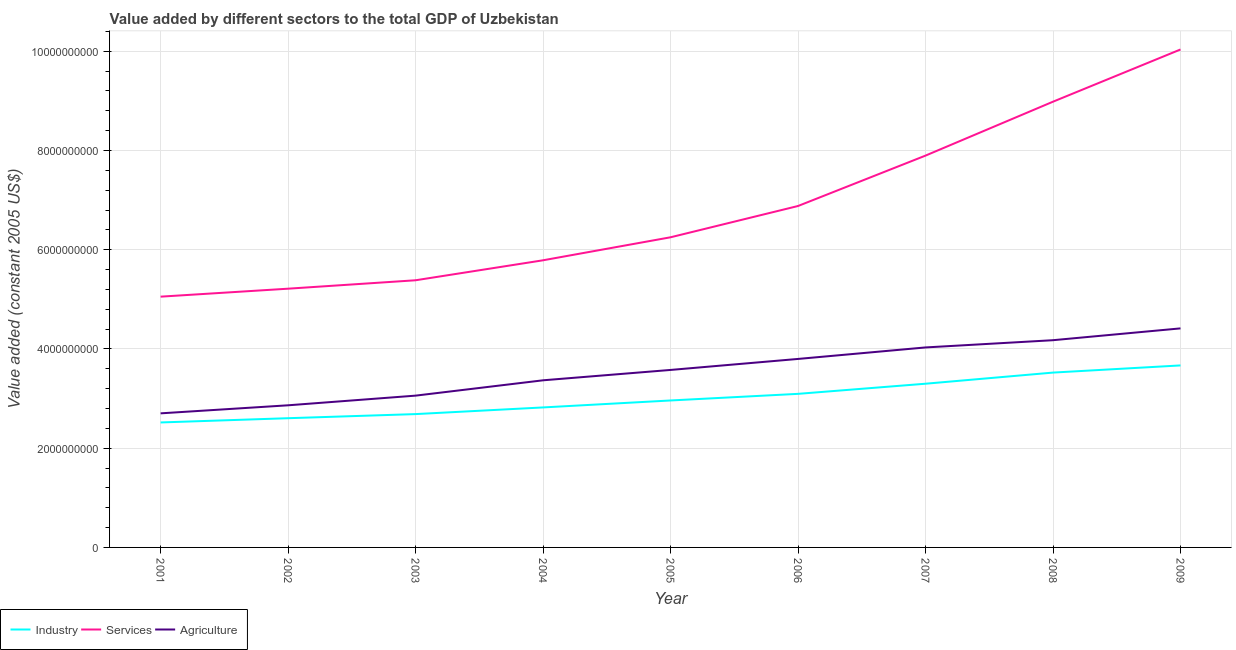How many different coloured lines are there?
Provide a succinct answer. 3. Does the line corresponding to value added by industrial sector intersect with the line corresponding to value added by agricultural sector?
Offer a very short reply. No. What is the value added by agricultural sector in 2001?
Give a very brief answer. 2.70e+09. Across all years, what is the maximum value added by agricultural sector?
Offer a very short reply. 4.41e+09. Across all years, what is the minimum value added by agricultural sector?
Provide a succinct answer. 2.70e+09. In which year was the value added by agricultural sector minimum?
Ensure brevity in your answer.  2001. What is the total value added by industrial sector in the graph?
Give a very brief answer. 2.72e+1. What is the difference between the value added by agricultural sector in 2002 and that in 2009?
Ensure brevity in your answer.  -1.55e+09. What is the difference between the value added by industrial sector in 2008 and the value added by agricultural sector in 2004?
Ensure brevity in your answer.  1.55e+08. What is the average value added by agricultural sector per year?
Your response must be concise. 3.55e+09. In the year 2004, what is the difference between the value added by industrial sector and value added by services?
Provide a succinct answer. -2.97e+09. What is the ratio of the value added by services in 2002 to that in 2009?
Your answer should be compact. 0.52. What is the difference between the highest and the second highest value added by industrial sector?
Your answer should be compact. 1.44e+08. What is the difference between the highest and the lowest value added by services?
Offer a very short reply. 4.98e+09. In how many years, is the value added by industrial sector greater than the average value added by industrial sector taken over all years?
Give a very brief answer. 4. Is the sum of the value added by services in 2002 and 2009 greater than the maximum value added by agricultural sector across all years?
Ensure brevity in your answer.  Yes. Is it the case that in every year, the sum of the value added by industrial sector and value added by services is greater than the value added by agricultural sector?
Offer a terse response. Yes. Is the value added by agricultural sector strictly less than the value added by services over the years?
Your answer should be compact. Yes. How many lines are there?
Provide a short and direct response. 3. What is the difference between two consecutive major ticks on the Y-axis?
Keep it short and to the point. 2.00e+09. Where does the legend appear in the graph?
Your answer should be compact. Bottom left. How many legend labels are there?
Your answer should be very brief. 3. What is the title of the graph?
Provide a succinct answer. Value added by different sectors to the total GDP of Uzbekistan. Does "Oil" appear as one of the legend labels in the graph?
Your answer should be compact. No. What is the label or title of the X-axis?
Give a very brief answer. Year. What is the label or title of the Y-axis?
Your answer should be compact. Value added (constant 2005 US$). What is the Value added (constant 2005 US$) of Industry in 2001?
Provide a succinct answer. 2.52e+09. What is the Value added (constant 2005 US$) in Services in 2001?
Provide a short and direct response. 5.05e+09. What is the Value added (constant 2005 US$) of Agriculture in 2001?
Provide a short and direct response. 2.70e+09. What is the Value added (constant 2005 US$) in Industry in 2002?
Your answer should be very brief. 2.60e+09. What is the Value added (constant 2005 US$) in Services in 2002?
Your answer should be very brief. 5.21e+09. What is the Value added (constant 2005 US$) of Agriculture in 2002?
Your answer should be compact. 2.86e+09. What is the Value added (constant 2005 US$) in Industry in 2003?
Give a very brief answer. 2.69e+09. What is the Value added (constant 2005 US$) of Services in 2003?
Provide a succinct answer. 5.38e+09. What is the Value added (constant 2005 US$) of Agriculture in 2003?
Provide a short and direct response. 3.06e+09. What is the Value added (constant 2005 US$) in Industry in 2004?
Offer a very short reply. 2.82e+09. What is the Value added (constant 2005 US$) of Services in 2004?
Offer a terse response. 5.79e+09. What is the Value added (constant 2005 US$) in Agriculture in 2004?
Keep it short and to the point. 3.37e+09. What is the Value added (constant 2005 US$) of Industry in 2005?
Keep it short and to the point. 2.96e+09. What is the Value added (constant 2005 US$) of Services in 2005?
Your answer should be compact. 6.25e+09. What is the Value added (constant 2005 US$) in Agriculture in 2005?
Offer a terse response. 3.58e+09. What is the Value added (constant 2005 US$) of Industry in 2006?
Your response must be concise. 3.09e+09. What is the Value added (constant 2005 US$) of Services in 2006?
Provide a short and direct response. 6.88e+09. What is the Value added (constant 2005 US$) of Agriculture in 2006?
Provide a succinct answer. 3.80e+09. What is the Value added (constant 2005 US$) in Industry in 2007?
Provide a succinct answer. 3.30e+09. What is the Value added (constant 2005 US$) in Services in 2007?
Give a very brief answer. 7.90e+09. What is the Value added (constant 2005 US$) in Agriculture in 2007?
Your response must be concise. 4.03e+09. What is the Value added (constant 2005 US$) in Industry in 2008?
Offer a terse response. 3.52e+09. What is the Value added (constant 2005 US$) in Services in 2008?
Offer a very short reply. 8.98e+09. What is the Value added (constant 2005 US$) of Agriculture in 2008?
Offer a terse response. 4.18e+09. What is the Value added (constant 2005 US$) in Industry in 2009?
Your answer should be compact. 3.67e+09. What is the Value added (constant 2005 US$) in Services in 2009?
Give a very brief answer. 1.00e+1. What is the Value added (constant 2005 US$) of Agriculture in 2009?
Your response must be concise. 4.41e+09. Across all years, what is the maximum Value added (constant 2005 US$) of Industry?
Offer a terse response. 3.67e+09. Across all years, what is the maximum Value added (constant 2005 US$) of Services?
Your answer should be compact. 1.00e+1. Across all years, what is the maximum Value added (constant 2005 US$) of Agriculture?
Give a very brief answer. 4.41e+09. Across all years, what is the minimum Value added (constant 2005 US$) of Industry?
Provide a succinct answer. 2.52e+09. Across all years, what is the minimum Value added (constant 2005 US$) in Services?
Give a very brief answer. 5.05e+09. Across all years, what is the minimum Value added (constant 2005 US$) of Agriculture?
Make the answer very short. 2.70e+09. What is the total Value added (constant 2005 US$) in Industry in the graph?
Offer a very short reply. 2.72e+1. What is the total Value added (constant 2005 US$) in Services in the graph?
Your answer should be compact. 6.15e+1. What is the total Value added (constant 2005 US$) of Agriculture in the graph?
Offer a terse response. 3.20e+1. What is the difference between the Value added (constant 2005 US$) in Industry in 2001 and that in 2002?
Your answer should be compact. -8.56e+07. What is the difference between the Value added (constant 2005 US$) in Services in 2001 and that in 2002?
Your response must be concise. -1.60e+08. What is the difference between the Value added (constant 2005 US$) of Agriculture in 2001 and that in 2002?
Your answer should be compact. -1.62e+08. What is the difference between the Value added (constant 2005 US$) in Industry in 2001 and that in 2003?
Provide a succinct answer. -1.68e+08. What is the difference between the Value added (constant 2005 US$) of Services in 2001 and that in 2003?
Offer a terse response. -3.30e+08. What is the difference between the Value added (constant 2005 US$) of Agriculture in 2001 and that in 2003?
Offer a very short reply. -3.57e+08. What is the difference between the Value added (constant 2005 US$) of Industry in 2001 and that in 2004?
Your answer should be compact. -3.03e+08. What is the difference between the Value added (constant 2005 US$) of Services in 2001 and that in 2004?
Give a very brief answer. -7.33e+08. What is the difference between the Value added (constant 2005 US$) of Agriculture in 2001 and that in 2004?
Ensure brevity in your answer.  -6.66e+08. What is the difference between the Value added (constant 2005 US$) of Industry in 2001 and that in 2005?
Make the answer very short. -4.43e+08. What is the difference between the Value added (constant 2005 US$) of Services in 2001 and that in 2005?
Offer a very short reply. -1.20e+09. What is the difference between the Value added (constant 2005 US$) in Agriculture in 2001 and that in 2005?
Your answer should be compact. -8.75e+08. What is the difference between the Value added (constant 2005 US$) in Industry in 2001 and that in 2006?
Offer a very short reply. -5.76e+08. What is the difference between the Value added (constant 2005 US$) in Services in 2001 and that in 2006?
Ensure brevity in your answer.  -1.83e+09. What is the difference between the Value added (constant 2005 US$) of Agriculture in 2001 and that in 2006?
Give a very brief answer. -1.10e+09. What is the difference between the Value added (constant 2005 US$) in Industry in 2001 and that in 2007?
Provide a succinct answer. -7.81e+08. What is the difference between the Value added (constant 2005 US$) of Services in 2001 and that in 2007?
Give a very brief answer. -2.84e+09. What is the difference between the Value added (constant 2005 US$) of Agriculture in 2001 and that in 2007?
Keep it short and to the point. -1.33e+09. What is the difference between the Value added (constant 2005 US$) in Industry in 2001 and that in 2008?
Keep it short and to the point. -1.00e+09. What is the difference between the Value added (constant 2005 US$) in Services in 2001 and that in 2008?
Your answer should be very brief. -3.93e+09. What is the difference between the Value added (constant 2005 US$) in Agriculture in 2001 and that in 2008?
Your response must be concise. -1.47e+09. What is the difference between the Value added (constant 2005 US$) in Industry in 2001 and that in 2009?
Your answer should be very brief. -1.15e+09. What is the difference between the Value added (constant 2005 US$) of Services in 2001 and that in 2009?
Offer a very short reply. -4.98e+09. What is the difference between the Value added (constant 2005 US$) in Agriculture in 2001 and that in 2009?
Provide a succinct answer. -1.71e+09. What is the difference between the Value added (constant 2005 US$) in Industry in 2002 and that in 2003?
Your answer should be compact. -8.27e+07. What is the difference between the Value added (constant 2005 US$) of Services in 2002 and that in 2003?
Provide a short and direct response. -1.70e+08. What is the difference between the Value added (constant 2005 US$) in Agriculture in 2002 and that in 2003?
Offer a very short reply. -1.95e+08. What is the difference between the Value added (constant 2005 US$) in Industry in 2002 and that in 2004?
Offer a terse response. -2.17e+08. What is the difference between the Value added (constant 2005 US$) of Services in 2002 and that in 2004?
Ensure brevity in your answer.  -5.72e+08. What is the difference between the Value added (constant 2005 US$) in Agriculture in 2002 and that in 2004?
Your answer should be compact. -5.04e+08. What is the difference between the Value added (constant 2005 US$) in Industry in 2002 and that in 2005?
Provide a short and direct response. -3.57e+08. What is the difference between the Value added (constant 2005 US$) of Services in 2002 and that in 2005?
Provide a short and direct response. -1.04e+09. What is the difference between the Value added (constant 2005 US$) in Agriculture in 2002 and that in 2005?
Offer a terse response. -7.13e+08. What is the difference between the Value added (constant 2005 US$) in Industry in 2002 and that in 2006?
Ensure brevity in your answer.  -4.91e+08. What is the difference between the Value added (constant 2005 US$) of Services in 2002 and that in 2006?
Offer a very short reply. -1.67e+09. What is the difference between the Value added (constant 2005 US$) of Agriculture in 2002 and that in 2006?
Provide a succinct answer. -9.34e+08. What is the difference between the Value added (constant 2005 US$) in Industry in 2002 and that in 2007?
Provide a succinct answer. -6.95e+08. What is the difference between the Value added (constant 2005 US$) of Services in 2002 and that in 2007?
Your answer should be very brief. -2.68e+09. What is the difference between the Value added (constant 2005 US$) in Agriculture in 2002 and that in 2007?
Your response must be concise. -1.17e+09. What is the difference between the Value added (constant 2005 US$) in Industry in 2002 and that in 2008?
Your response must be concise. -9.19e+08. What is the difference between the Value added (constant 2005 US$) of Services in 2002 and that in 2008?
Provide a short and direct response. -3.77e+09. What is the difference between the Value added (constant 2005 US$) in Agriculture in 2002 and that in 2008?
Offer a very short reply. -1.31e+09. What is the difference between the Value added (constant 2005 US$) in Industry in 2002 and that in 2009?
Make the answer very short. -1.06e+09. What is the difference between the Value added (constant 2005 US$) in Services in 2002 and that in 2009?
Ensure brevity in your answer.  -4.82e+09. What is the difference between the Value added (constant 2005 US$) in Agriculture in 2002 and that in 2009?
Keep it short and to the point. -1.55e+09. What is the difference between the Value added (constant 2005 US$) in Industry in 2003 and that in 2004?
Ensure brevity in your answer.  -1.34e+08. What is the difference between the Value added (constant 2005 US$) in Services in 2003 and that in 2004?
Provide a succinct answer. -4.03e+08. What is the difference between the Value added (constant 2005 US$) in Agriculture in 2003 and that in 2004?
Offer a terse response. -3.09e+08. What is the difference between the Value added (constant 2005 US$) in Industry in 2003 and that in 2005?
Ensure brevity in your answer.  -2.75e+08. What is the difference between the Value added (constant 2005 US$) in Services in 2003 and that in 2005?
Make the answer very short. -8.66e+08. What is the difference between the Value added (constant 2005 US$) in Agriculture in 2003 and that in 2005?
Provide a short and direct response. -5.18e+08. What is the difference between the Value added (constant 2005 US$) in Industry in 2003 and that in 2006?
Offer a very short reply. -4.08e+08. What is the difference between the Value added (constant 2005 US$) in Services in 2003 and that in 2006?
Your response must be concise. -1.50e+09. What is the difference between the Value added (constant 2005 US$) of Agriculture in 2003 and that in 2006?
Your response must be concise. -7.40e+08. What is the difference between the Value added (constant 2005 US$) in Industry in 2003 and that in 2007?
Provide a succinct answer. -6.12e+08. What is the difference between the Value added (constant 2005 US$) in Services in 2003 and that in 2007?
Offer a terse response. -2.51e+09. What is the difference between the Value added (constant 2005 US$) in Agriculture in 2003 and that in 2007?
Your answer should be very brief. -9.71e+08. What is the difference between the Value added (constant 2005 US$) of Industry in 2003 and that in 2008?
Offer a terse response. -8.37e+08. What is the difference between the Value added (constant 2005 US$) of Services in 2003 and that in 2008?
Make the answer very short. -3.60e+09. What is the difference between the Value added (constant 2005 US$) in Agriculture in 2003 and that in 2008?
Provide a succinct answer. -1.12e+09. What is the difference between the Value added (constant 2005 US$) of Industry in 2003 and that in 2009?
Give a very brief answer. -9.81e+08. What is the difference between the Value added (constant 2005 US$) in Services in 2003 and that in 2009?
Give a very brief answer. -4.65e+09. What is the difference between the Value added (constant 2005 US$) in Agriculture in 2003 and that in 2009?
Keep it short and to the point. -1.36e+09. What is the difference between the Value added (constant 2005 US$) of Industry in 2004 and that in 2005?
Your answer should be compact. -1.40e+08. What is the difference between the Value added (constant 2005 US$) of Services in 2004 and that in 2005?
Offer a terse response. -4.64e+08. What is the difference between the Value added (constant 2005 US$) in Agriculture in 2004 and that in 2005?
Provide a succinct answer. -2.09e+08. What is the difference between the Value added (constant 2005 US$) in Industry in 2004 and that in 2006?
Provide a succinct answer. -2.74e+08. What is the difference between the Value added (constant 2005 US$) of Services in 2004 and that in 2006?
Provide a short and direct response. -1.09e+09. What is the difference between the Value added (constant 2005 US$) in Agriculture in 2004 and that in 2006?
Your answer should be compact. -4.31e+08. What is the difference between the Value added (constant 2005 US$) in Industry in 2004 and that in 2007?
Give a very brief answer. -4.78e+08. What is the difference between the Value added (constant 2005 US$) of Services in 2004 and that in 2007?
Make the answer very short. -2.11e+09. What is the difference between the Value added (constant 2005 US$) of Agriculture in 2004 and that in 2007?
Offer a very short reply. -6.62e+08. What is the difference between the Value added (constant 2005 US$) of Industry in 2004 and that in 2008?
Keep it short and to the point. -7.02e+08. What is the difference between the Value added (constant 2005 US$) in Services in 2004 and that in 2008?
Your response must be concise. -3.20e+09. What is the difference between the Value added (constant 2005 US$) of Agriculture in 2004 and that in 2008?
Make the answer very short. -8.08e+08. What is the difference between the Value added (constant 2005 US$) of Industry in 2004 and that in 2009?
Your answer should be very brief. -8.47e+08. What is the difference between the Value added (constant 2005 US$) in Services in 2004 and that in 2009?
Your response must be concise. -4.25e+09. What is the difference between the Value added (constant 2005 US$) in Agriculture in 2004 and that in 2009?
Offer a terse response. -1.05e+09. What is the difference between the Value added (constant 2005 US$) in Industry in 2005 and that in 2006?
Your answer should be compact. -1.33e+08. What is the difference between the Value added (constant 2005 US$) of Services in 2005 and that in 2006?
Offer a very short reply. -6.30e+08. What is the difference between the Value added (constant 2005 US$) in Agriculture in 2005 and that in 2006?
Provide a short and direct response. -2.22e+08. What is the difference between the Value added (constant 2005 US$) of Industry in 2005 and that in 2007?
Ensure brevity in your answer.  -3.38e+08. What is the difference between the Value added (constant 2005 US$) of Services in 2005 and that in 2007?
Your response must be concise. -1.65e+09. What is the difference between the Value added (constant 2005 US$) of Agriculture in 2005 and that in 2007?
Offer a terse response. -4.53e+08. What is the difference between the Value added (constant 2005 US$) of Industry in 2005 and that in 2008?
Provide a short and direct response. -5.62e+08. What is the difference between the Value added (constant 2005 US$) in Services in 2005 and that in 2008?
Provide a short and direct response. -2.73e+09. What is the difference between the Value added (constant 2005 US$) of Agriculture in 2005 and that in 2008?
Your answer should be compact. -5.99e+08. What is the difference between the Value added (constant 2005 US$) in Industry in 2005 and that in 2009?
Your answer should be compact. -7.06e+08. What is the difference between the Value added (constant 2005 US$) in Services in 2005 and that in 2009?
Offer a very short reply. -3.78e+09. What is the difference between the Value added (constant 2005 US$) of Agriculture in 2005 and that in 2009?
Offer a terse response. -8.37e+08. What is the difference between the Value added (constant 2005 US$) in Industry in 2006 and that in 2007?
Your answer should be very brief. -2.04e+08. What is the difference between the Value added (constant 2005 US$) in Services in 2006 and that in 2007?
Provide a short and direct response. -1.02e+09. What is the difference between the Value added (constant 2005 US$) in Agriculture in 2006 and that in 2007?
Your answer should be very brief. -2.32e+08. What is the difference between the Value added (constant 2005 US$) of Industry in 2006 and that in 2008?
Give a very brief answer. -4.29e+08. What is the difference between the Value added (constant 2005 US$) of Services in 2006 and that in 2008?
Give a very brief answer. -2.10e+09. What is the difference between the Value added (constant 2005 US$) in Agriculture in 2006 and that in 2008?
Give a very brief answer. -3.78e+08. What is the difference between the Value added (constant 2005 US$) of Industry in 2006 and that in 2009?
Your response must be concise. -5.73e+08. What is the difference between the Value added (constant 2005 US$) in Services in 2006 and that in 2009?
Keep it short and to the point. -3.15e+09. What is the difference between the Value added (constant 2005 US$) of Agriculture in 2006 and that in 2009?
Provide a succinct answer. -6.16e+08. What is the difference between the Value added (constant 2005 US$) in Industry in 2007 and that in 2008?
Your response must be concise. -2.24e+08. What is the difference between the Value added (constant 2005 US$) in Services in 2007 and that in 2008?
Offer a terse response. -1.09e+09. What is the difference between the Value added (constant 2005 US$) of Agriculture in 2007 and that in 2008?
Provide a succinct answer. -1.46e+08. What is the difference between the Value added (constant 2005 US$) of Industry in 2007 and that in 2009?
Your answer should be compact. -3.69e+08. What is the difference between the Value added (constant 2005 US$) in Services in 2007 and that in 2009?
Your answer should be compact. -2.14e+09. What is the difference between the Value added (constant 2005 US$) in Agriculture in 2007 and that in 2009?
Provide a succinct answer. -3.84e+08. What is the difference between the Value added (constant 2005 US$) in Industry in 2008 and that in 2009?
Offer a very short reply. -1.44e+08. What is the difference between the Value added (constant 2005 US$) in Services in 2008 and that in 2009?
Give a very brief answer. -1.05e+09. What is the difference between the Value added (constant 2005 US$) of Agriculture in 2008 and that in 2009?
Provide a succinct answer. -2.38e+08. What is the difference between the Value added (constant 2005 US$) of Industry in 2001 and the Value added (constant 2005 US$) of Services in 2002?
Your answer should be compact. -2.70e+09. What is the difference between the Value added (constant 2005 US$) in Industry in 2001 and the Value added (constant 2005 US$) in Agriculture in 2002?
Your answer should be very brief. -3.46e+08. What is the difference between the Value added (constant 2005 US$) in Services in 2001 and the Value added (constant 2005 US$) in Agriculture in 2002?
Give a very brief answer. 2.19e+09. What is the difference between the Value added (constant 2005 US$) of Industry in 2001 and the Value added (constant 2005 US$) of Services in 2003?
Ensure brevity in your answer.  -2.87e+09. What is the difference between the Value added (constant 2005 US$) in Industry in 2001 and the Value added (constant 2005 US$) in Agriculture in 2003?
Offer a very short reply. -5.41e+08. What is the difference between the Value added (constant 2005 US$) of Services in 2001 and the Value added (constant 2005 US$) of Agriculture in 2003?
Offer a very short reply. 1.99e+09. What is the difference between the Value added (constant 2005 US$) in Industry in 2001 and the Value added (constant 2005 US$) in Services in 2004?
Your response must be concise. -3.27e+09. What is the difference between the Value added (constant 2005 US$) of Industry in 2001 and the Value added (constant 2005 US$) of Agriculture in 2004?
Your answer should be compact. -8.49e+08. What is the difference between the Value added (constant 2005 US$) of Services in 2001 and the Value added (constant 2005 US$) of Agriculture in 2004?
Your response must be concise. 1.69e+09. What is the difference between the Value added (constant 2005 US$) of Industry in 2001 and the Value added (constant 2005 US$) of Services in 2005?
Provide a succinct answer. -3.73e+09. What is the difference between the Value added (constant 2005 US$) of Industry in 2001 and the Value added (constant 2005 US$) of Agriculture in 2005?
Keep it short and to the point. -1.06e+09. What is the difference between the Value added (constant 2005 US$) in Services in 2001 and the Value added (constant 2005 US$) in Agriculture in 2005?
Provide a short and direct response. 1.48e+09. What is the difference between the Value added (constant 2005 US$) in Industry in 2001 and the Value added (constant 2005 US$) in Services in 2006?
Keep it short and to the point. -4.36e+09. What is the difference between the Value added (constant 2005 US$) in Industry in 2001 and the Value added (constant 2005 US$) in Agriculture in 2006?
Give a very brief answer. -1.28e+09. What is the difference between the Value added (constant 2005 US$) in Services in 2001 and the Value added (constant 2005 US$) in Agriculture in 2006?
Give a very brief answer. 1.26e+09. What is the difference between the Value added (constant 2005 US$) of Industry in 2001 and the Value added (constant 2005 US$) of Services in 2007?
Your response must be concise. -5.38e+09. What is the difference between the Value added (constant 2005 US$) in Industry in 2001 and the Value added (constant 2005 US$) in Agriculture in 2007?
Ensure brevity in your answer.  -1.51e+09. What is the difference between the Value added (constant 2005 US$) of Services in 2001 and the Value added (constant 2005 US$) of Agriculture in 2007?
Make the answer very short. 1.02e+09. What is the difference between the Value added (constant 2005 US$) of Industry in 2001 and the Value added (constant 2005 US$) of Services in 2008?
Provide a succinct answer. -6.46e+09. What is the difference between the Value added (constant 2005 US$) of Industry in 2001 and the Value added (constant 2005 US$) of Agriculture in 2008?
Your answer should be very brief. -1.66e+09. What is the difference between the Value added (constant 2005 US$) in Services in 2001 and the Value added (constant 2005 US$) in Agriculture in 2008?
Make the answer very short. 8.78e+08. What is the difference between the Value added (constant 2005 US$) in Industry in 2001 and the Value added (constant 2005 US$) in Services in 2009?
Keep it short and to the point. -7.52e+09. What is the difference between the Value added (constant 2005 US$) in Industry in 2001 and the Value added (constant 2005 US$) in Agriculture in 2009?
Your answer should be compact. -1.90e+09. What is the difference between the Value added (constant 2005 US$) of Services in 2001 and the Value added (constant 2005 US$) of Agriculture in 2009?
Give a very brief answer. 6.40e+08. What is the difference between the Value added (constant 2005 US$) of Industry in 2002 and the Value added (constant 2005 US$) of Services in 2003?
Keep it short and to the point. -2.78e+09. What is the difference between the Value added (constant 2005 US$) in Industry in 2002 and the Value added (constant 2005 US$) in Agriculture in 2003?
Provide a succinct answer. -4.55e+08. What is the difference between the Value added (constant 2005 US$) in Services in 2002 and the Value added (constant 2005 US$) in Agriculture in 2003?
Ensure brevity in your answer.  2.16e+09. What is the difference between the Value added (constant 2005 US$) in Industry in 2002 and the Value added (constant 2005 US$) in Services in 2004?
Your response must be concise. -3.18e+09. What is the difference between the Value added (constant 2005 US$) in Industry in 2002 and the Value added (constant 2005 US$) in Agriculture in 2004?
Your response must be concise. -7.64e+08. What is the difference between the Value added (constant 2005 US$) in Services in 2002 and the Value added (constant 2005 US$) in Agriculture in 2004?
Your answer should be compact. 1.85e+09. What is the difference between the Value added (constant 2005 US$) in Industry in 2002 and the Value added (constant 2005 US$) in Services in 2005?
Offer a very short reply. -3.65e+09. What is the difference between the Value added (constant 2005 US$) in Industry in 2002 and the Value added (constant 2005 US$) in Agriculture in 2005?
Offer a very short reply. -9.73e+08. What is the difference between the Value added (constant 2005 US$) in Services in 2002 and the Value added (constant 2005 US$) in Agriculture in 2005?
Provide a short and direct response. 1.64e+09. What is the difference between the Value added (constant 2005 US$) in Industry in 2002 and the Value added (constant 2005 US$) in Services in 2006?
Give a very brief answer. -4.28e+09. What is the difference between the Value added (constant 2005 US$) of Industry in 2002 and the Value added (constant 2005 US$) of Agriculture in 2006?
Provide a succinct answer. -1.19e+09. What is the difference between the Value added (constant 2005 US$) of Services in 2002 and the Value added (constant 2005 US$) of Agriculture in 2006?
Ensure brevity in your answer.  1.42e+09. What is the difference between the Value added (constant 2005 US$) of Industry in 2002 and the Value added (constant 2005 US$) of Services in 2007?
Provide a succinct answer. -5.29e+09. What is the difference between the Value added (constant 2005 US$) in Industry in 2002 and the Value added (constant 2005 US$) in Agriculture in 2007?
Offer a very short reply. -1.43e+09. What is the difference between the Value added (constant 2005 US$) of Services in 2002 and the Value added (constant 2005 US$) of Agriculture in 2007?
Your response must be concise. 1.18e+09. What is the difference between the Value added (constant 2005 US$) in Industry in 2002 and the Value added (constant 2005 US$) in Services in 2008?
Your answer should be compact. -6.38e+09. What is the difference between the Value added (constant 2005 US$) in Industry in 2002 and the Value added (constant 2005 US$) in Agriculture in 2008?
Your response must be concise. -1.57e+09. What is the difference between the Value added (constant 2005 US$) of Services in 2002 and the Value added (constant 2005 US$) of Agriculture in 2008?
Your answer should be compact. 1.04e+09. What is the difference between the Value added (constant 2005 US$) of Industry in 2002 and the Value added (constant 2005 US$) of Services in 2009?
Provide a short and direct response. -7.43e+09. What is the difference between the Value added (constant 2005 US$) in Industry in 2002 and the Value added (constant 2005 US$) in Agriculture in 2009?
Ensure brevity in your answer.  -1.81e+09. What is the difference between the Value added (constant 2005 US$) of Services in 2002 and the Value added (constant 2005 US$) of Agriculture in 2009?
Keep it short and to the point. 8.00e+08. What is the difference between the Value added (constant 2005 US$) of Industry in 2003 and the Value added (constant 2005 US$) of Services in 2004?
Keep it short and to the point. -3.10e+09. What is the difference between the Value added (constant 2005 US$) of Industry in 2003 and the Value added (constant 2005 US$) of Agriculture in 2004?
Ensure brevity in your answer.  -6.81e+08. What is the difference between the Value added (constant 2005 US$) in Services in 2003 and the Value added (constant 2005 US$) in Agriculture in 2004?
Give a very brief answer. 2.02e+09. What is the difference between the Value added (constant 2005 US$) of Industry in 2003 and the Value added (constant 2005 US$) of Services in 2005?
Give a very brief answer. -3.56e+09. What is the difference between the Value added (constant 2005 US$) of Industry in 2003 and the Value added (constant 2005 US$) of Agriculture in 2005?
Make the answer very short. -8.90e+08. What is the difference between the Value added (constant 2005 US$) of Services in 2003 and the Value added (constant 2005 US$) of Agriculture in 2005?
Your answer should be very brief. 1.81e+09. What is the difference between the Value added (constant 2005 US$) in Industry in 2003 and the Value added (constant 2005 US$) in Services in 2006?
Make the answer very short. -4.19e+09. What is the difference between the Value added (constant 2005 US$) of Industry in 2003 and the Value added (constant 2005 US$) of Agriculture in 2006?
Keep it short and to the point. -1.11e+09. What is the difference between the Value added (constant 2005 US$) in Services in 2003 and the Value added (constant 2005 US$) in Agriculture in 2006?
Your answer should be compact. 1.59e+09. What is the difference between the Value added (constant 2005 US$) in Industry in 2003 and the Value added (constant 2005 US$) in Services in 2007?
Your answer should be compact. -5.21e+09. What is the difference between the Value added (constant 2005 US$) of Industry in 2003 and the Value added (constant 2005 US$) of Agriculture in 2007?
Make the answer very short. -1.34e+09. What is the difference between the Value added (constant 2005 US$) of Services in 2003 and the Value added (constant 2005 US$) of Agriculture in 2007?
Give a very brief answer. 1.35e+09. What is the difference between the Value added (constant 2005 US$) of Industry in 2003 and the Value added (constant 2005 US$) of Services in 2008?
Your answer should be compact. -6.30e+09. What is the difference between the Value added (constant 2005 US$) of Industry in 2003 and the Value added (constant 2005 US$) of Agriculture in 2008?
Provide a short and direct response. -1.49e+09. What is the difference between the Value added (constant 2005 US$) of Services in 2003 and the Value added (constant 2005 US$) of Agriculture in 2008?
Give a very brief answer. 1.21e+09. What is the difference between the Value added (constant 2005 US$) of Industry in 2003 and the Value added (constant 2005 US$) of Services in 2009?
Your answer should be compact. -7.35e+09. What is the difference between the Value added (constant 2005 US$) in Industry in 2003 and the Value added (constant 2005 US$) in Agriculture in 2009?
Provide a short and direct response. -1.73e+09. What is the difference between the Value added (constant 2005 US$) of Services in 2003 and the Value added (constant 2005 US$) of Agriculture in 2009?
Offer a terse response. 9.70e+08. What is the difference between the Value added (constant 2005 US$) of Industry in 2004 and the Value added (constant 2005 US$) of Services in 2005?
Offer a very short reply. -3.43e+09. What is the difference between the Value added (constant 2005 US$) of Industry in 2004 and the Value added (constant 2005 US$) of Agriculture in 2005?
Your answer should be very brief. -7.56e+08. What is the difference between the Value added (constant 2005 US$) in Services in 2004 and the Value added (constant 2005 US$) in Agriculture in 2005?
Provide a succinct answer. 2.21e+09. What is the difference between the Value added (constant 2005 US$) of Industry in 2004 and the Value added (constant 2005 US$) of Services in 2006?
Provide a short and direct response. -4.06e+09. What is the difference between the Value added (constant 2005 US$) in Industry in 2004 and the Value added (constant 2005 US$) in Agriculture in 2006?
Provide a short and direct response. -9.77e+08. What is the difference between the Value added (constant 2005 US$) in Services in 2004 and the Value added (constant 2005 US$) in Agriculture in 2006?
Provide a succinct answer. 1.99e+09. What is the difference between the Value added (constant 2005 US$) in Industry in 2004 and the Value added (constant 2005 US$) in Services in 2007?
Your answer should be compact. -5.08e+09. What is the difference between the Value added (constant 2005 US$) of Industry in 2004 and the Value added (constant 2005 US$) of Agriculture in 2007?
Give a very brief answer. -1.21e+09. What is the difference between the Value added (constant 2005 US$) of Services in 2004 and the Value added (constant 2005 US$) of Agriculture in 2007?
Your answer should be very brief. 1.76e+09. What is the difference between the Value added (constant 2005 US$) in Industry in 2004 and the Value added (constant 2005 US$) in Services in 2008?
Give a very brief answer. -6.16e+09. What is the difference between the Value added (constant 2005 US$) of Industry in 2004 and the Value added (constant 2005 US$) of Agriculture in 2008?
Make the answer very short. -1.35e+09. What is the difference between the Value added (constant 2005 US$) of Services in 2004 and the Value added (constant 2005 US$) of Agriculture in 2008?
Offer a terse response. 1.61e+09. What is the difference between the Value added (constant 2005 US$) of Industry in 2004 and the Value added (constant 2005 US$) of Services in 2009?
Keep it short and to the point. -7.21e+09. What is the difference between the Value added (constant 2005 US$) in Industry in 2004 and the Value added (constant 2005 US$) in Agriculture in 2009?
Your response must be concise. -1.59e+09. What is the difference between the Value added (constant 2005 US$) in Services in 2004 and the Value added (constant 2005 US$) in Agriculture in 2009?
Your answer should be very brief. 1.37e+09. What is the difference between the Value added (constant 2005 US$) in Industry in 2005 and the Value added (constant 2005 US$) in Services in 2006?
Your answer should be very brief. -3.92e+09. What is the difference between the Value added (constant 2005 US$) of Industry in 2005 and the Value added (constant 2005 US$) of Agriculture in 2006?
Keep it short and to the point. -8.37e+08. What is the difference between the Value added (constant 2005 US$) of Services in 2005 and the Value added (constant 2005 US$) of Agriculture in 2006?
Keep it short and to the point. 2.45e+09. What is the difference between the Value added (constant 2005 US$) of Industry in 2005 and the Value added (constant 2005 US$) of Services in 2007?
Your answer should be very brief. -4.93e+09. What is the difference between the Value added (constant 2005 US$) in Industry in 2005 and the Value added (constant 2005 US$) in Agriculture in 2007?
Give a very brief answer. -1.07e+09. What is the difference between the Value added (constant 2005 US$) of Services in 2005 and the Value added (constant 2005 US$) of Agriculture in 2007?
Your response must be concise. 2.22e+09. What is the difference between the Value added (constant 2005 US$) in Industry in 2005 and the Value added (constant 2005 US$) in Services in 2008?
Keep it short and to the point. -6.02e+09. What is the difference between the Value added (constant 2005 US$) of Industry in 2005 and the Value added (constant 2005 US$) of Agriculture in 2008?
Offer a terse response. -1.21e+09. What is the difference between the Value added (constant 2005 US$) in Services in 2005 and the Value added (constant 2005 US$) in Agriculture in 2008?
Your response must be concise. 2.07e+09. What is the difference between the Value added (constant 2005 US$) in Industry in 2005 and the Value added (constant 2005 US$) in Services in 2009?
Your answer should be very brief. -7.07e+09. What is the difference between the Value added (constant 2005 US$) of Industry in 2005 and the Value added (constant 2005 US$) of Agriculture in 2009?
Offer a very short reply. -1.45e+09. What is the difference between the Value added (constant 2005 US$) in Services in 2005 and the Value added (constant 2005 US$) in Agriculture in 2009?
Offer a terse response. 1.84e+09. What is the difference between the Value added (constant 2005 US$) in Industry in 2006 and the Value added (constant 2005 US$) in Services in 2007?
Ensure brevity in your answer.  -4.80e+09. What is the difference between the Value added (constant 2005 US$) in Industry in 2006 and the Value added (constant 2005 US$) in Agriculture in 2007?
Provide a short and direct response. -9.35e+08. What is the difference between the Value added (constant 2005 US$) of Services in 2006 and the Value added (constant 2005 US$) of Agriculture in 2007?
Keep it short and to the point. 2.85e+09. What is the difference between the Value added (constant 2005 US$) of Industry in 2006 and the Value added (constant 2005 US$) of Services in 2008?
Your answer should be compact. -5.89e+09. What is the difference between the Value added (constant 2005 US$) of Industry in 2006 and the Value added (constant 2005 US$) of Agriculture in 2008?
Your answer should be very brief. -1.08e+09. What is the difference between the Value added (constant 2005 US$) of Services in 2006 and the Value added (constant 2005 US$) of Agriculture in 2008?
Give a very brief answer. 2.70e+09. What is the difference between the Value added (constant 2005 US$) in Industry in 2006 and the Value added (constant 2005 US$) in Services in 2009?
Provide a succinct answer. -6.94e+09. What is the difference between the Value added (constant 2005 US$) in Industry in 2006 and the Value added (constant 2005 US$) in Agriculture in 2009?
Keep it short and to the point. -1.32e+09. What is the difference between the Value added (constant 2005 US$) of Services in 2006 and the Value added (constant 2005 US$) of Agriculture in 2009?
Keep it short and to the point. 2.47e+09. What is the difference between the Value added (constant 2005 US$) of Industry in 2007 and the Value added (constant 2005 US$) of Services in 2008?
Offer a very short reply. -5.68e+09. What is the difference between the Value added (constant 2005 US$) of Industry in 2007 and the Value added (constant 2005 US$) of Agriculture in 2008?
Make the answer very short. -8.77e+08. What is the difference between the Value added (constant 2005 US$) in Services in 2007 and the Value added (constant 2005 US$) in Agriculture in 2008?
Provide a succinct answer. 3.72e+09. What is the difference between the Value added (constant 2005 US$) in Industry in 2007 and the Value added (constant 2005 US$) in Services in 2009?
Offer a very short reply. -6.74e+09. What is the difference between the Value added (constant 2005 US$) of Industry in 2007 and the Value added (constant 2005 US$) of Agriculture in 2009?
Your answer should be compact. -1.12e+09. What is the difference between the Value added (constant 2005 US$) of Services in 2007 and the Value added (constant 2005 US$) of Agriculture in 2009?
Your answer should be compact. 3.48e+09. What is the difference between the Value added (constant 2005 US$) of Industry in 2008 and the Value added (constant 2005 US$) of Services in 2009?
Keep it short and to the point. -6.51e+09. What is the difference between the Value added (constant 2005 US$) in Industry in 2008 and the Value added (constant 2005 US$) in Agriculture in 2009?
Keep it short and to the point. -8.91e+08. What is the difference between the Value added (constant 2005 US$) of Services in 2008 and the Value added (constant 2005 US$) of Agriculture in 2009?
Give a very brief answer. 4.57e+09. What is the average Value added (constant 2005 US$) of Industry per year?
Make the answer very short. 3.02e+09. What is the average Value added (constant 2005 US$) in Services per year?
Provide a succinct answer. 6.83e+09. What is the average Value added (constant 2005 US$) in Agriculture per year?
Make the answer very short. 3.55e+09. In the year 2001, what is the difference between the Value added (constant 2005 US$) of Industry and Value added (constant 2005 US$) of Services?
Make the answer very short. -2.54e+09. In the year 2001, what is the difference between the Value added (constant 2005 US$) of Industry and Value added (constant 2005 US$) of Agriculture?
Make the answer very short. -1.84e+08. In the year 2001, what is the difference between the Value added (constant 2005 US$) of Services and Value added (constant 2005 US$) of Agriculture?
Your answer should be very brief. 2.35e+09. In the year 2002, what is the difference between the Value added (constant 2005 US$) in Industry and Value added (constant 2005 US$) in Services?
Your response must be concise. -2.61e+09. In the year 2002, what is the difference between the Value added (constant 2005 US$) of Industry and Value added (constant 2005 US$) of Agriculture?
Your response must be concise. -2.60e+08. In the year 2002, what is the difference between the Value added (constant 2005 US$) in Services and Value added (constant 2005 US$) in Agriculture?
Your answer should be very brief. 2.35e+09. In the year 2003, what is the difference between the Value added (constant 2005 US$) of Industry and Value added (constant 2005 US$) of Services?
Provide a succinct answer. -2.70e+09. In the year 2003, what is the difference between the Value added (constant 2005 US$) in Industry and Value added (constant 2005 US$) in Agriculture?
Offer a very short reply. -3.72e+08. In the year 2003, what is the difference between the Value added (constant 2005 US$) in Services and Value added (constant 2005 US$) in Agriculture?
Your answer should be very brief. 2.32e+09. In the year 2004, what is the difference between the Value added (constant 2005 US$) in Industry and Value added (constant 2005 US$) in Services?
Provide a succinct answer. -2.97e+09. In the year 2004, what is the difference between the Value added (constant 2005 US$) in Industry and Value added (constant 2005 US$) in Agriculture?
Offer a very short reply. -5.47e+08. In the year 2004, what is the difference between the Value added (constant 2005 US$) in Services and Value added (constant 2005 US$) in Agriculture?
Provide a succinct answer. 2.42e+09. In the year 2005, what is the difference between the Value added (constant 2005 US$) of Industry and Value added (constant 2005 US$) of Services?
Your answer should be very brief. -3.29e+09. In the year 2005, what is the difference between the Value added (constant 2005 US$) in Industry and Value added (constant 2005 US$) in Agriculture?
Your response must be concise. -6.15e+08. In the year 2005, what is the difference between the Value added (constant 2005 US$) of Services and Value added (constant 2005 US$) of Agriculture?
Make the answer very short. 2.67e+09. In the year 2006, what is the difference between the Value added (constant 2005 US$) in Industry and Value added (constant 2005 US$) in Services?
Offer a very short reply. -3.79e+09. In the year 2006, what is the difference between the Value added (constant 2005 US$) of Industry and Value added (constant 2005 US$) of Agriculture?
Give a very brief answer. -7.04e+08. In the year 2006, what is the difference between the Value added (constant 2005 US$) in Services and Value added (constant 2005 US$) in Agriculture?
Your answer should be compact. 3.08e+09. In the year 2007, what is the difference between the Value added (constant 2005 US$) of Industry and Value added (constant 2005 US$) of Services?
Provide a succinct answer. -4.60e+09. In the year 2007, what is the difference between the Value added (constant 2005 US$) of Industry and Value added (constant 2005 US$) of Agriculture?
Make the answer very short. -7.31e+08. In the year 2007, what is the difference between the Value added (constant 2005 US$) in Services and Value added (constant 2005 US$) in Agriculture?
Your answer should be compact. 3.87e+09. In the year 2008, what is the difference between the Value added (constant 2005 US$) of Industry and Value added (constant 2005 US$) of Services?
Your answer should be very brief. -5.46e+09. In the year 2008, what is the difference between the Value added (constant 2005 US$) in Industry and Value added (constant 2005 US$) in Agriculture?
Ensure brevity in your answer.  -6.53e+08. In the year 2008, what is the difference between the Value added (constant 2005 US$) of Services and Value added (constant 2005 US$) of Agriculture?
Provide a succinct answer. 4.81e+09. In the year 2009, what is the difference between the Value added (constant 2005 US$) in Industry and Value added (constant 2005 US$) in Services?
Your answer should be compact. -6.37e+09. In the year 2009, what is the difference between the Value added (constant 2005 US$) in Industry and Value added (constant 2005 US$) in Agriculture?
Offer a very short reply. -7.46e+08. In the year 2009, what is the difference between the Value added (constant 2005 US$) in Services and Value added (constant 2005 US$) in Agriculture?
Offer a very short reply. 5.62e+09. What is the ratio of the Value added (constant 2005 US$) of Industry in 2001 to that in 2002?
Offer a terse response. 0.97. What is the ratio of the Value added (constant 2005 US$) in Services in 2001 to that in 2002?
Offer a very short reply. 0.97. What is the ratio of the Value added (constant 2005 US$) in Agriculture in 2001 to that in 2002?
Your response must be concise. 0.94. What is the ratio of the Value added (constant 2005 US$) of Industry in 2001 to that in 2003?
Offer a terse response. 0.94. What is the ratio of the Value added (constant 2005 US$) of Services in 2001 to that in 2003?
Your answer should be very brief. 0.94. What is the ratio of the Value added (constant 2005 US$) in Agriculture in 2001 to that in 2003?
Offer a terse response. 0.88. What is the ratio of the Value added (constant 2005 US$) in Industry in 2001 to that in 2004?
Offer a terse response. 0.89. What is the ratio of the Value added (constant 2005 US$) of Services in 2001 to that in 2004?
Your answer should be very brief. 0.87. What is the ratio of the Value added (constant 2005 US$) of Agriculture in 2001 to that in 2004?
Your response must be concise. 0.8. What is the ratio of the Value added (constant 2005 US$) of Industry in 2001 to that in 2005?
Provide a succinct answer. 0.85. What is the ratio of the Value added (constant 2005 US$) in Services in 2001 to that in 2005?
Provide a succinct answer. 0.81. What is the ratio of the Value added (constant 2005 US$) of Agriculture in 2001 to that in 2005?
Provide a succinct answer. 0.76. What is the ratio of the Value added (constant 2005 US$) in Industry in 2001 to that in 2006?
Your response must be concise. 0.81. What is the ratio of the Value added (constant 2005 US$) of Services in 2001 to that in 2006?
Your response must be concise. 0.73. What is the ratio of the Value added (constant 2005 US$) of Agriculture in 2001 to that in 2006?
Provide a short and direct response. 0.71. What is the ratio of the Value added (constant 2005 US$) of Industry in 2001 to that in 2007?
Ensure brevity in your answer.  0.76. What is the ratio of the Value added (constant 2005 US$) of Services in 2001 to that in 2007?
Your response must be concise. 0.64. What is the ratio of the Value added (constant 2005 US$) of Agriculture in 2001 to that in 2007?
Your response must be concise. 0.67. What is the ratio of the Value added (constant 2005 US$) in Industry in 2001 to that in 2008?
Provide a short and direct response. 0.71. What is the ratio of the Value added (constant 2005 US$) in Services in 2001 to that in 2008?
Ensure brevity in your answer.  0.56. What is the ratio of the Value added (constant 2005 US$) of Agriculture in 2001 to that in 2008?
Provide a succinct answer. 0.65. What is the ratio of the Value added (constant 2005 US$) of Industry in 2001 to that in 2009?
Your response must be concise. 0.69. What is the ratio of the Value added (constant 2005 US$) of Services in 2001 to that in 2009?
Offer a very short reply. 0.5. What is the ratio of the Value added (constant 2005 US$) of Agriculture in 2001 to that in 2009?
Your answer should be very brief. 0.61. What is the ratio of the Value added (constant 2005 US$) in Industry in 2002 to that in 2003?
Make the answer very short. 0.97. What is the ratio of the Value added (constant 2005 US$) in Services in 2002 to that in 2003?
Make the answer very short. 0.97. What is the ratio of the Value added (constant 2005 US$) in Agriculture in 2002 to that in 2003?
Your answer should be compact. 0.94. What is the ratio of the Value added (constant 2005 US$) in Industry in 2002 to that in 2004?
Provide a short and direct response. 0.92. What is the ratio of the Value added (constant 2005 US$) in Services in 2002 to that in 2004?
Make the answer very short. 0.9. What is the ratio of the Value added (constant 2005 US$) in Agriculture in 2002 to that in 2004?
Offer a terse response. 0.85. What is the ratio of the Value added (constant 2005 US$) in Industry in 2002 to that in 2005?
Your response must be concise. 0.88. What is the ratio of the Value added (constant 2005 US$) in Services in 2002 to that in 2005?
Keep it short and to the point. 0.83. What is the ratio of the Value added (constant 2005 US$) in Agriculture in 2002 to that in 2005?
Your answer should be very brief. 0.8. What is the ratio of the Value added (constant 2005 US$) of Industry in 2002 to that in 2006?
Offer a terse response. 0.84. What is the ratio of the Value added (constant 2005 US$) of Services in 2002 to that in 2006?
Your answer should be very brief. 0.76. What is the ratio of the Value added (constant 2005 US$) in Agriculture in 2002 to that in 2006?
Make the answer very short. 0.75. What is the ratio of the Value added (constant 2005 US$) of Industry in 2002 to that in 2007?
Ensure brevity in your answer.  0.79. What is the ratio of the Value added (constant 2005 US$) of Services in 2002 to that in 2007?
Your answer should be compact. 0.66. What is the ratio of the Value added (constant 2005 US$) in Agriculture in 2002 to that in 2007?
Ensure brevity in your answer.  0.71. What is the ratio of the Value added (constant 2005 US$) of Industry in 2002 to that in 2008?
Give a very brief answer. 0.74. What is the ratio of the Value added (constant 2005 US$) of Services in 2002 to that in 2008?
Give a very brief answer. 0.58. What is the ratio of the Value added (constant 2005 US$) in Agriculture in 2002 to that in 2008?
Ensure brevity in your answer.  0.69. What is the ratio of the Value added (constant 2005 US$) of Industry in 2002 to that in 2009?
Make the answer very short. 0.71. What is the ratio of the Value added (constant 2005 US$) of Services in 2002 to that in 2009?
Give a very brief answer. 0.52. What is the ratio of the Value added (constant 2005 US$) in Agriculture in 2002 to that in 2009?
Keep it short and to the point. 0.65. What is the ratio of the Value added (constant 2005 US$) in Industry in 2003 to that in 2004?
Your answer should be compact. 0.95. What is the ratio of the Value added (constant 2005 US$) of Services in 2003 to that in 2004?
Your answer should be very brief. 0.93. What is the ratio of the Value added (constant 2005 US$) of Agriculture in 2003 to that in 2004?
Your answer should be compact. 0.91. What is the ratio of the Value added (constant 2005 US$) in Industry in 2003 to that in 2005?
Ensure brevity in your answer.  0.91. What is the ratio of the Value added (constant 2005 US$) of Services in 2003 to that in 2005?
Offer a very short reply. 0.86. What is the ratio of the Value added (constant 2005 US$) of Agriculture in 2003 to that in 2005?
Ensure brevity in your answer.  0.86. What is the ratio of the Value added (constant 2005 US$) of Industry in 2003 to that in 2006?
Your answer should be compact. 0.87. What is the ratio of the Value added (constant 2005 US$) in Services in 2003 to that in 2006?
Provide a short and direct response. 0.78. What is the ratio of the Value added (constant 2005 US$) in Agriculture in 2003 to that in 2006?
Provide a succinct answer. 0.81. What is the ratio of the Value added (constant 2005 US$) in Industry in 2003 to that in 2007?
Offer a very short reply. 0.81. What is the ratio of the Value added (constant 2005 US$) of Services in 2003 to that in 2007?
Make the answer very short. 0.68. What is the ratio of the Value added (constant 2005 US$) of Agriculture in 2003 to that in 2007?
Offer a terse response. 0.76. What is the ratio of the Value added (constant 2005 US$) in Industry in 2003 to that in 2008?
Your answer should be compact. 0.76. What is the ratio of the Value added (constant 2005 US$) of Services in 2003 to that in 2008?
Your answer should be very brief. 0.6. What is the ratio of the Value added (constant 2005 US$) in Agriculture in 2003 to that in 2008?
Your answer should be very brief. 0.73. What is the ratio of the Value added (constant 2005 US$) in Industry in 2003 to that in 2009?
Offer a very short reply. 0.73. What is the ratio of the Value added (constant 2005 US$) in Services in 2003 to that in 2009?
Keep it short and to the point. 0.54. What is the ratio of the Value added (constant 2005 US$) in Agriculture in 2003 to that in 2009?
Provide a succinct answer. 0.69. What is the ratio of the Value added (constant 2005 US$) in Industry in 2004 to that in 2005?
Offer a terse response. 0.95. What is the ratio of the Value added (constant 2005 US$) in Services in 2004 to that in 2005?
Offer a very short reply. 0.93. What is the ratio of the Value added (constant 2005 US$) of Agriculture in 2004 to that in 2005?
Offer a very short reply. 0.94. What is the ratio of the Value added (constant 2005 US$) of Industry in 2004 to that in 2006?
Give a very brief answer. 0.91. What is the ratio of the Value added (constant 2005 US$) in Services in 2004 to that in 2006?
Give a very brief answer. 0.84. What is the ratio of the Value added (constant 2005 US$) of Agriculture in 2004 to that in 2006?
Provide a succinct answer. 0.89. What is the ratio of the Value added (constant 2005 US$) of Industry in 2004 to that in 2007?
Your response must be concise. 0.86. What is the ratio of the Value added (constant 2005 US$) of Services in 2004 to that in 2007?
Provide a succinct answer. 0.73. What is the ratio of the Value added (constant 2005 US$) in Agriculture in 2004 to that in 2007?
Your answer should be very brief. 0.84. What is the ratio of the Value added (constant 2005 US$) of Industry in 2004 to that in 2008?
Your response must be concise. 0.8. What is the ratio of the Value added (constant 2005 US$) in Services in 2004 to that in 2008?
Ensure brevity in your answer.  0.64. What is the ratio of the Value added (constant 2005 US$) in Agriculture in 2004 to that in 2008?
Ensure brevity in your answer.  0.81. What is the ratio of the Value added (constant 2005 US$) of Industry in 2004 to that in 2009?
Give a very brief answer. 0.77. What is the ratio of the Value added (constant 2005 US$) in Services in 2004 to that in 2009?
Ensure brevity in your answer.  0.58. What is the ratio of the Value added (constant 2005 US$) of Agriculture in 2004 to that in 2009?
Keep it short and to the point. 0.76. What is the ratio of the Value added (constant 2005 US$) of Industry in 2005 to that in 2006?
Your answer should be compact. 0.96. What is the ratio of the Value added (constant 2005 US$) in Services in 2005 to that in 2006?
Offer a very short reply. 0.91. What is the ratio of the Value added (constant 2005 US$) in Agriculture in 2005 to that in 2006?
Your answer should be very brief. 0.94. What is the ratio of the Value added (constant 2005 US$) of Industry in 2005 to that in 2007?
Provide a short and direct response. 0.9. What is the ratio of the Value added (constant 2005 US$) in Services in 2005 to that in 2007?
Keep it short and to the point. 0.79. What is the ratio of the Value added (constant 2005 US$) in Agriculture in 2005 to that in 2007?
Provide a succinct answer. 0.89. What is the ratio of the Value added (constant 2005 US$) in Industry in 2005 to that in 2008?
Offer a terse response. 0.84. What is the ratio of the Value added (constant 2005 US$) in Services in 2005 to that in 2008?
Provide a short and direct response. 0.7. What is the ratio of the Value added (constant 2005 US$) of Agriculture in 2005 to that in 2008?
Make the answer very short. 0.86. What is the ratio of the Value added (constant 2005 US$) of Industry in 2005 to that in 2009?
Keep it short and to the point. 0.81. What is the ratio of the Value added (constant 2005 US$) in Services in 2005 to that in 2009?
Keep it short and to the point. 0.62. What is the ratio of the Value added (constant 2005 US$) of Agriculture in 2005 to that in 2009?
Ensure brevity in your answer.  0.81. What is the ratio of the Value added (constant 2005 US$) in Industry in 2006 to that in 2007?
Ensure brevity in your answer.  0.94. What is the ratio of the Value added (constant 2005 US$) of Services in 2006 to that in 2007?
Your response must be concise. 0.87. What is the ratio of the Value added (constant 2005 US$) in Agriculture in 2006 to that in 2007?
Ensure brevity in your answer.  0.94. What is the ratio of the Value added (constant 2005 US$) of Industry in 2006 to that in 2008?
Your response must be concise. 0.88. What is the ratio of the Value added (constant 2005 US$) of Services in 2006 to that in 2008?
Give a very brief answer. 0.77. What is the ratio of the Value added (constant 2005 US$) in Agriculture in 2006 to that in 2008?
Offer a terse response. 0.91. What is the ratio of the Value added (constant 2005 US$) of Industry in 2006 to that in 2009?
Your response must be concise. 0.84. What is the ratio of the Value added (constant 2005 US$) in Services in 2006 to that in 2009?
Offer a terse response. 0.69. What is the ratio of the Value added (constant 2005 US$) in Agriculture in 2006 to that in 2009?
Give a very brief answer. 0.86. What is the ratio of the Value added (constant 2005 US$) in Industry in 2007 to that in 2008?
Your response must be concise. 0.94. What is the ratio of the Value added (constant 2005 US$) of Services in 2007 to that in 2008?
Keep it short and to the point. 0.88. What is the ratio of the Value added (constant 2005 US$) of Agriculture in 2007 to that in 2008?
Offer a terse response. 0.97. What is the ratio of the Value added (constant 2005 US$) in Industry in 2007 to that in 2009?
Offer a very short reply. 0.9. What is the ratio of the Value added (constant 2005 US$) in Services in 2007 to that in 2009?
Offer a terse response. 0.79. What is the ratio of the Value added (constant 2005 US$) of Agriculture in 2007 to that in 2009?
Ensure brevity in your answer.  0.91. What is the ratio of the Value added (constant 2005 US$) in Industry in 2008 to that in 2009?
Make the answer very short. 0.96. What is the ratio of the Value added (constant 2005 US$) in Services in 2008 to that in 2009?
Provide a short and direct response. 0.9. What is the ratio of the Value added (constant 2005 US$) of Agriculture in 2008 to that in 2009?
Keep it short and to the point. 0.95. What is the difference between the highest and the second highest Value added (constant 2005 US$) in Industry?
Provide a short and direct response. 1.44e+08. What is the difference between the highest and the second highest Value added (constant 2005 US$) in Services?
Provide a succinct answer. 1.05e+09. What is the difference between the highest and the second highest Value added (constant 2005 US$) of Agriculture?
Give a very brief answer. 2.38e+08. What is the difference between the highest and the lowest Value added (constant 2005 US$) in Industry?
Make the answer very short. 1.15e+09. What is the difference between the highest and the lowest Value added (constant 2005 US$) of Services?
Give a very brief answer. 4.98e+09. What is the difference between the highest and the lowest Value added (constant 2005 US$) of Agriculture?
Offer a terse response. 1.71e+09. 